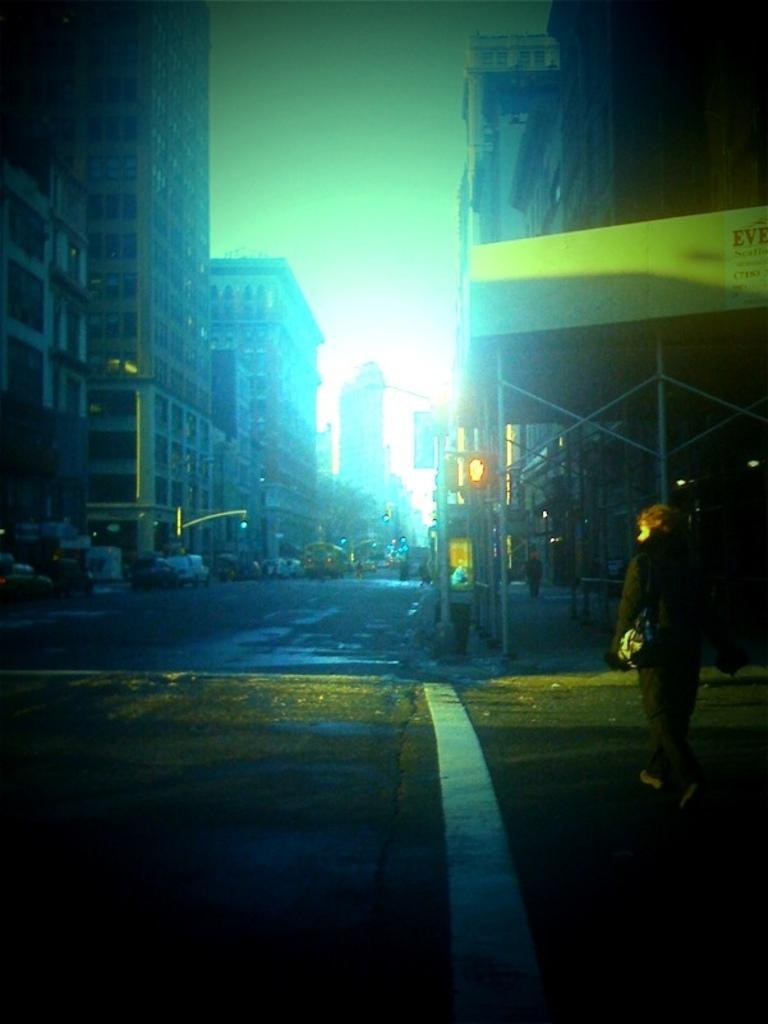Could you give a brief overview of what you see in this image? In the image we can see there is a person standing on the road and there are cars parked on the road. Behind there are buildings. 